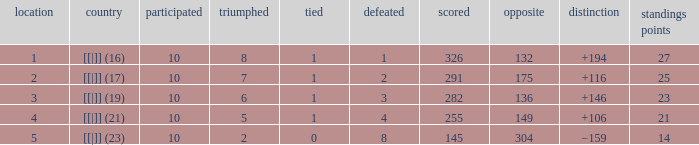 How many table points are listed for the deficit is +194?  1.0. Can you give me this table as a dict? {'header': ['location', 'country', 'participated', 'triumphed', 'tied', 'defeated', 'scored', 'opposite', 'distinction', 'standings points'], 'rows': [['1', '[[|]] (16)', '10', '8', '1', '1', '326', '132', '+194', '27'], ['2', '[[|]] (17)', '10', '7', '1', '2', '291', '175', '+116', '25'], ['3', '[[|]] (19)', '10', '6', '1', '3', '282', '136', '+146', '23'], ['4', '[[|]] (21)', '10', '5', '1', '4', '255', '149', '+106', '21'], ['5', '[[|]] (23)', '10', '2', '0', '8', '145', '304', '−159', '14']]} 